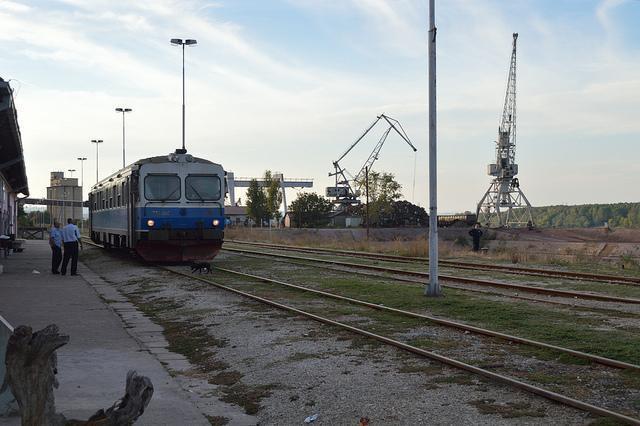Which entity is in the greatest danger?
Indicate the correct response by choosing from the four available options to answer the question.
Options: Dog, tall man, short man, right man. Dog. 